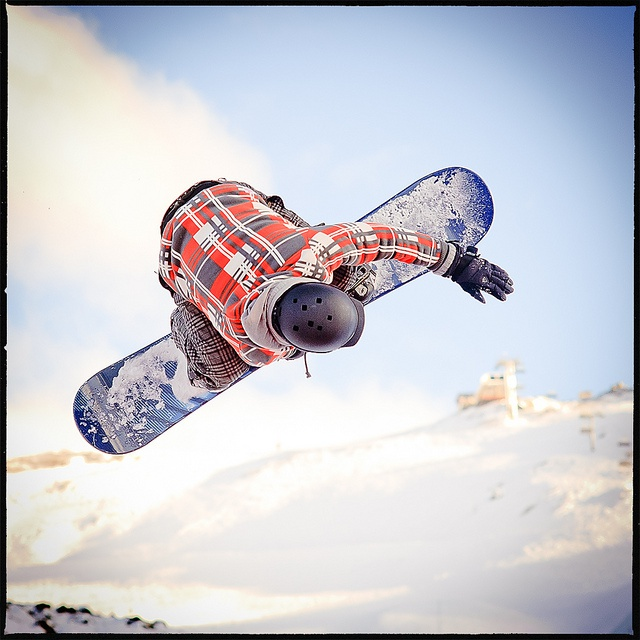Describe the objects in this image and their specific colors. I can see people in black, white, darkgray, and gray tones and snowboard in black, lightgray, darkgray, gray, and navy tones in this image. 